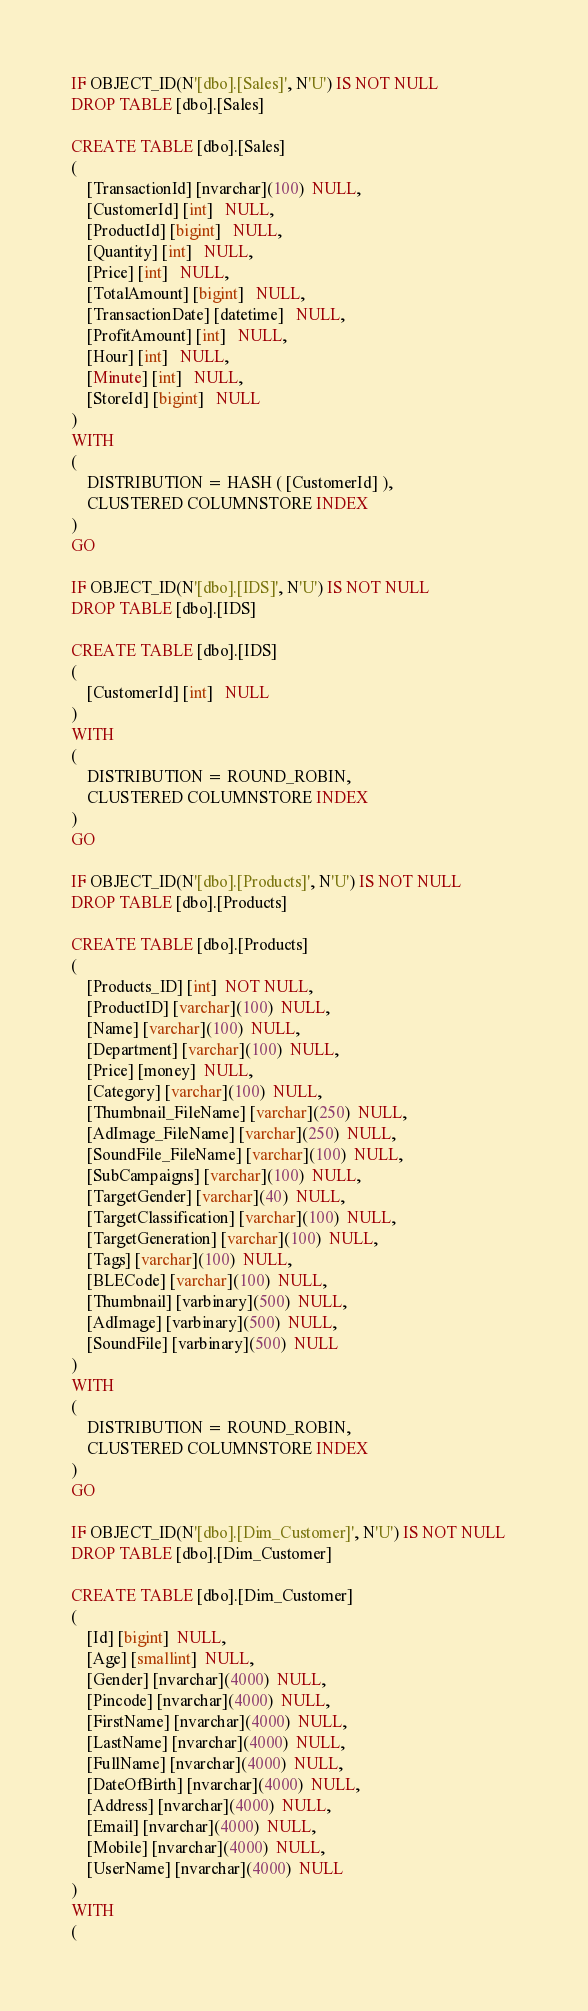<code> <loc_0><loc_0><loc_500><loc_500><_SQL_>IF OBJECT_ID(N'[dbo].[Sales]', N'U') IS NOT NULL   
DROP TABLE [dbo].[Sales]

CREATE TABLE [dbo].[Sales]
( 
	[TransactionId] [nvarchar](100)  NULL,
	[CustomerId] [int]   NULL,
	[ProductId] [bigint]   NULL,
	[Quantity] [int]   NULL,
	[Price] [int]   NULL,
	[TotalAmount] [bigint]   NULL,
	[TransactionDate] [datetime]   NULL,
	[ProfitAmount] [int]   NULL,
	[Hour] [int]   NULL,
	[Minute] [int]   NULL,
	[StoreId] [bigint]   NULL
)
WITH
(
	DISTRIBUTION = HASH ( [CustomerId] ),
	CLUSTERED COLUMNSTORE INDEX
)
GO

IF OBJECT_ID(N'[dbo].[IDS]', N'U') IS NOT NULL   
DROP TABLE [dbo].[IDS]

CREATE TABLE [dbo].[IDS]
( 
	[CustomerId] [int]   NULL
)
WITH
(
	DISTRIBUTION = ROUND_ROBIN,
	CLUSTERED COLUMNSTORE INDEX
)
GO

IF OBJECT_ID(N'[dbo].[Products]', N'U') IS NOT NULL   
DROP TABLE [dbo].[Products]

CREATE TABLE [dbo].[Products]
( 
	[Products_ID] [int]  NOT NULL,
	[ProductID] [varchar](100)  NULL,
	[Name] [varchar](100)  NULL,
	[Department] [varchar](100)  NULL,
	[Price] [money]  NULL,
	[Category] [varchar](100)  NULL,
	[Thumbnail_FileName] [varchar](250)  NULL,
	[AdImage_FileName] [varchar](250)  NULL,
	[SoundFile_FileName] [varchar](100)  NULL,
	[SubCampaigns] [varchar](100)  NULL,
	[TargetGender] [varchar](40)  NULL,
	[TargetClassification] [varchar](100)  NULL,
	[TargetGeneration] [varchar](100)  NULL,
	[Tags] [varchar](100)  NULL,
	[BLECode] [varchar](100)  NULL,
	[Thumbnail] [varbinary](500)  NULL,
	[AdImage] [varbinary](500)  NULL,
	[SoundFile] [varbinary](500)  NULL
)
WITH
(
	DISTRIBUTION = ROUND_ROBIN,
	CLUSTERED COLUMNSTORE INDEX
)
GO

IF OBJECT_ID(N'[dbo].[Dim_Customer]', N'U') IS NOT NULL   
DROP TABLE [dbo].[Dim_Customer]

CREATE TABLE [dbo].[Dim_Customer]
( 
	[Id] [bigint]  NULL,
	[Age] [smallint]  NULL,
	[Gender] [nvarchar](4000)  NULL,
	[Pincode] [nvarchar](4000)  NULL,
	[FirstName] [nvarchar](4000)  NULL,
	[LastName] [nvarchar](4000)  NULL,
	[FullName] [nvarchar](4000)  NULL,
	[DateOfBirth] [nvarchar](4000)  NULL,
	[Address] [nvarchar](4000)  NULL,
	[Email] [nvarchar](4000)  NULL,
	[Mobile] [nvarchar](4000)  NULL,
	[UserName] [nvarchar](4000)  NULL
)
WITH
(</code> 